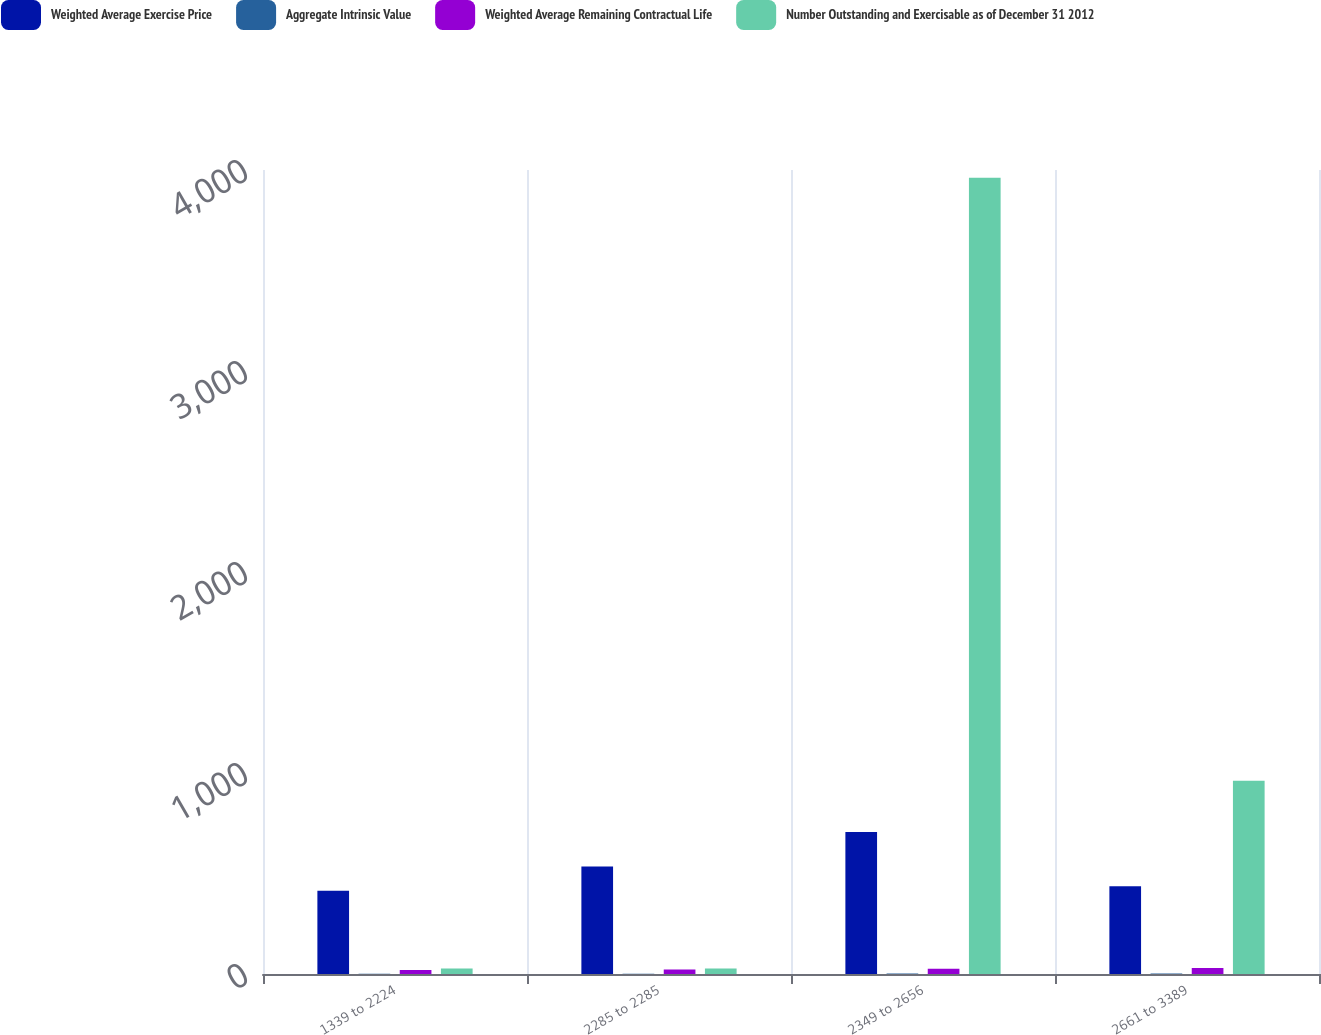Convert chart. <chart><loc_0><loc_0><loc_500><loc_500><stacked_bar_chart><ecel><fcel>1339 to 2224<fcel>2285 to 2285<fcel>2349 to 2656<fcel>2661 to 3389<nl><fcel>Weighted Average Exercise Price<fcel>414<fcel>535<fcel>706<fcel>436<nl><fcel>Aggregate Intrinsic Value<fcel>0.65<fcel>0.81<fcel>1.88<fcel>2.05<nl><fcel>Weighted Average Remaining Contractual Life<fcel>19.87<fcel>22.85<fcel>26.21<fcel>29.61<nl><fcel>Number Outstanding and Exercisable as of December 31 2012<fcel>27.91<fcel>27.91<fcel>3961<fcel>962<nl></chart> 